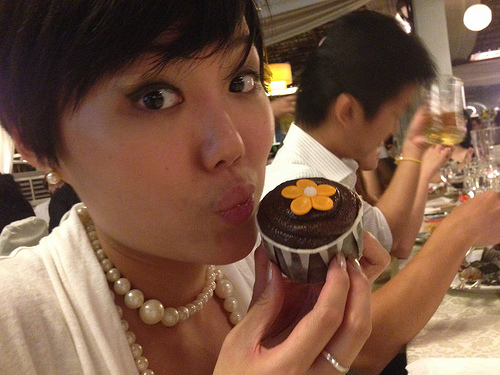Do you see any clocks there? No, there are no clocks visible in the image. 